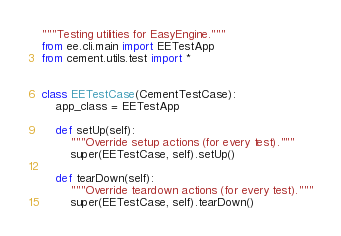<code> <loc_0><loc_0><loc_500><loc_500><_Python_>"""Testing utilities for EasyEngine."""
from ee.cli.main import EETestApp
from cement.utils.test import *


class EETestCase(CementTestCase):
    app_class = EETestApp

    def setUp(self):
        """Override setup actions (for every test)."""
        super(EETestCase, self).setUp()

    def tearDown(self):
        """Override teardown actions (for every test)."""
        super(EETestCase, self).tearDown()
</code> 